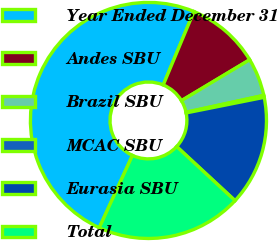<chart> <loc_0><loc_0><loc_500><loc_500><pie_chart><fcel>Year Ended December 31<fcel>Andes SBU<fcel>Brazil SBU<fcel>MCAC SBU<fcel>Eurasia SBU<fcel>Total<nl><fcel>49.46%<fcel>10.11%<fcel>5.19%<fcel>0.27%<fcel>15.03%<fcel>19.95%<nl></chart> 